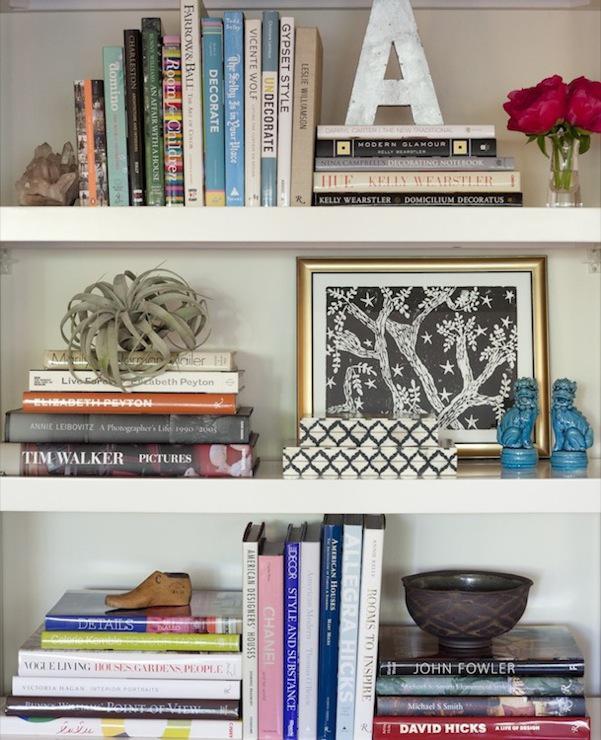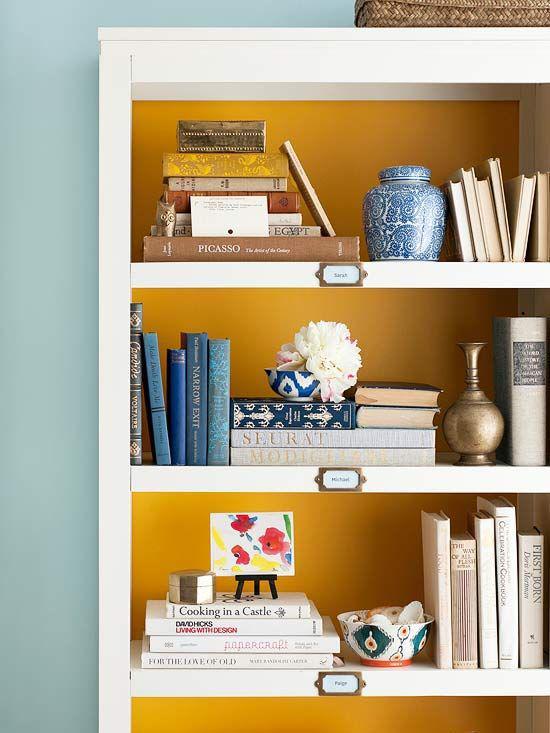The first image is the image on the left, the second image is the image on the right. Given the left and right images, does the statement "In one image, at least one lamp and seating are next to a shelving unit." hold true? Answer yes or no. No. The first image is the image on the left, the second image is the image on the right. Evaluate the accuracy of this statement regarding the images: "An image includes at least one dark bookcase.". Is it true? Answer yes or no. No. 